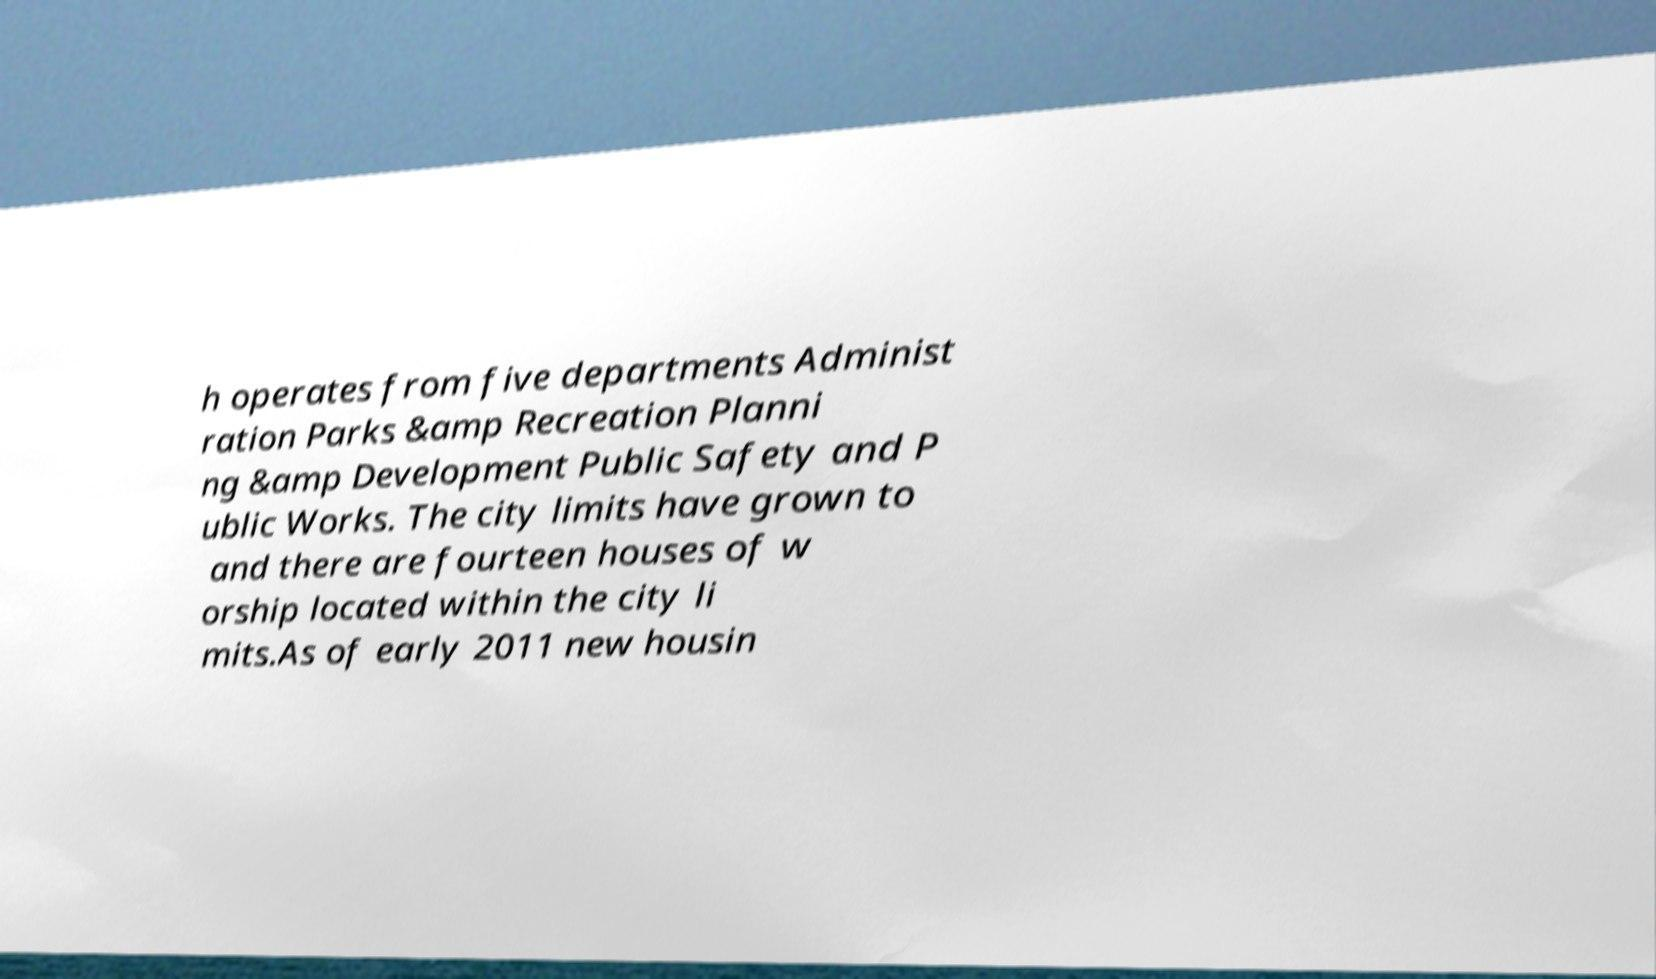Could you assist in decoding the text presented in this image and type it out clearly? h operates from five departments Administ ration Parks &amp Recreation Planni ng &amp Development Public Safety and P ublic Works. The city limits have grown to and there are fourteen houses of w orship located within the city li mits.As of early 2011 new housin 